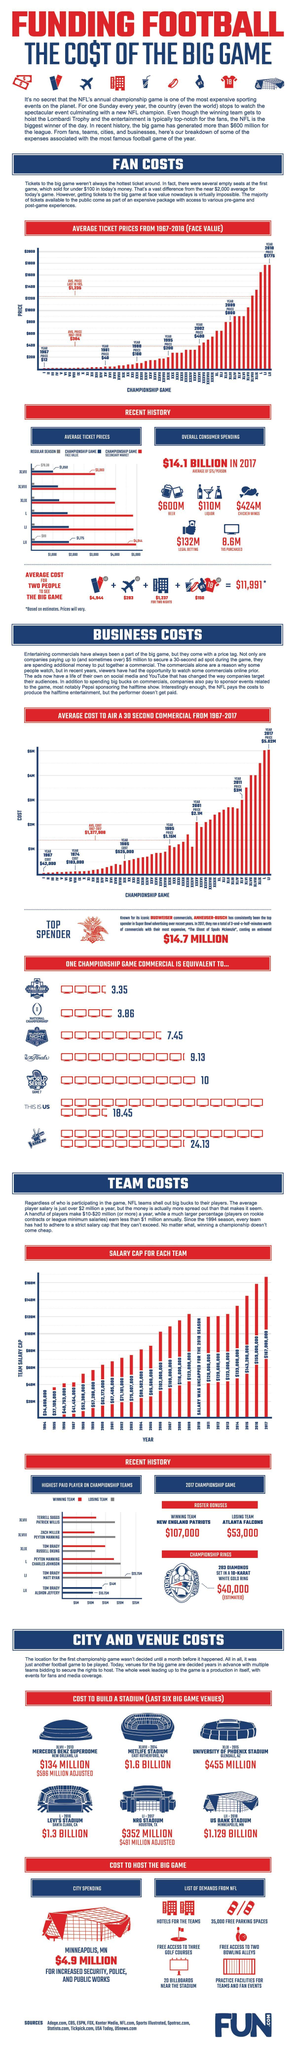In which stadium, the NFL Championship game XLIX were conducted in 2015?
Answer the question with a short phrase. UNIVERSITY OF PHOENIX STADIUM What is the average cost for flight tickets of two people to watch an NFL Championship game in 2017? $283 What is the average face value of Championship game XLVII  tickets in 2017? $1,050 What is the average price of an NFL ticket for two people in 2017? $4,944 How much did the fans of NFL Championship games spend on legal betting in the year 2017? $132M What is the average ticket price for NFL Championship game XLIII in the year 2009? $800 What is the cost of building Levi's stadium for NFL Championship game L in 2016? $1.3 BILLION What is the average ticket price for NFL Championship games during 1967-2018? $384 What is the cost of building US bank stadium for NFL Championship game LII in 2018? $1.129 BILLION In which stadium, the NFL Championship game XLVIII were conducted in 2014? METLIFE STADIUM 